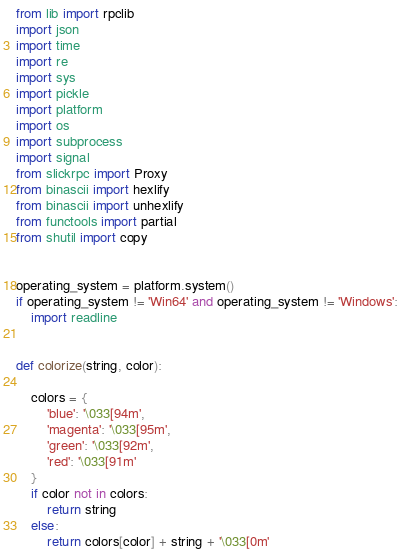<code> <loc_0><loc_0><loc_500><loc_500><_Python_>from lib import rpclib
import json
import time
import re
import sys
import pickle
import platform
import os
import subprocess
import signal
from slickrpc import Proxy
from binascii import hexlify
from binascii import unhexlify
from functools import partial
from shutil import copy


operating_system = platform.system()
if operating_system != 'Win64' and operating_system != 'Windows':
    import readline


def colorize(string, color):

    colors = {
        'blue': '\033[94m',
        'magenta': '\033[95m',
        'green': '\033[92m',
        'red': '\033[91m'
    }
    if color not in colors:
        return string
    else:
        return colors[color] + string + '\033[0m'

</code> 